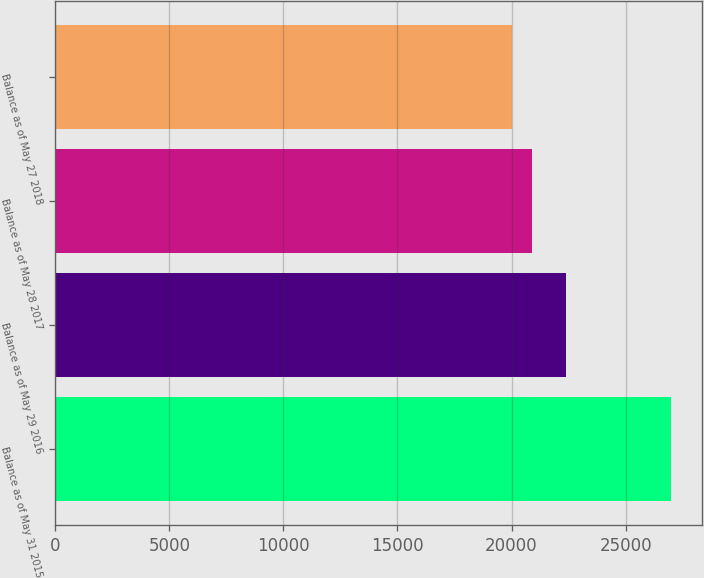Convert chart to OTSL. <chart><loc_0><loc_0><loc_500><loc_500><bar_chart><fcel>Balance as of May 31 2015<fcel>Balance as of May 29 2016<fcel>Balance as of May 28 2017<fcel>Balance as of May 27 2018<nl><fcel>26991.5<fcel>22385.1<fcel>20899.2<fcel>20021.1<nl></chart> 